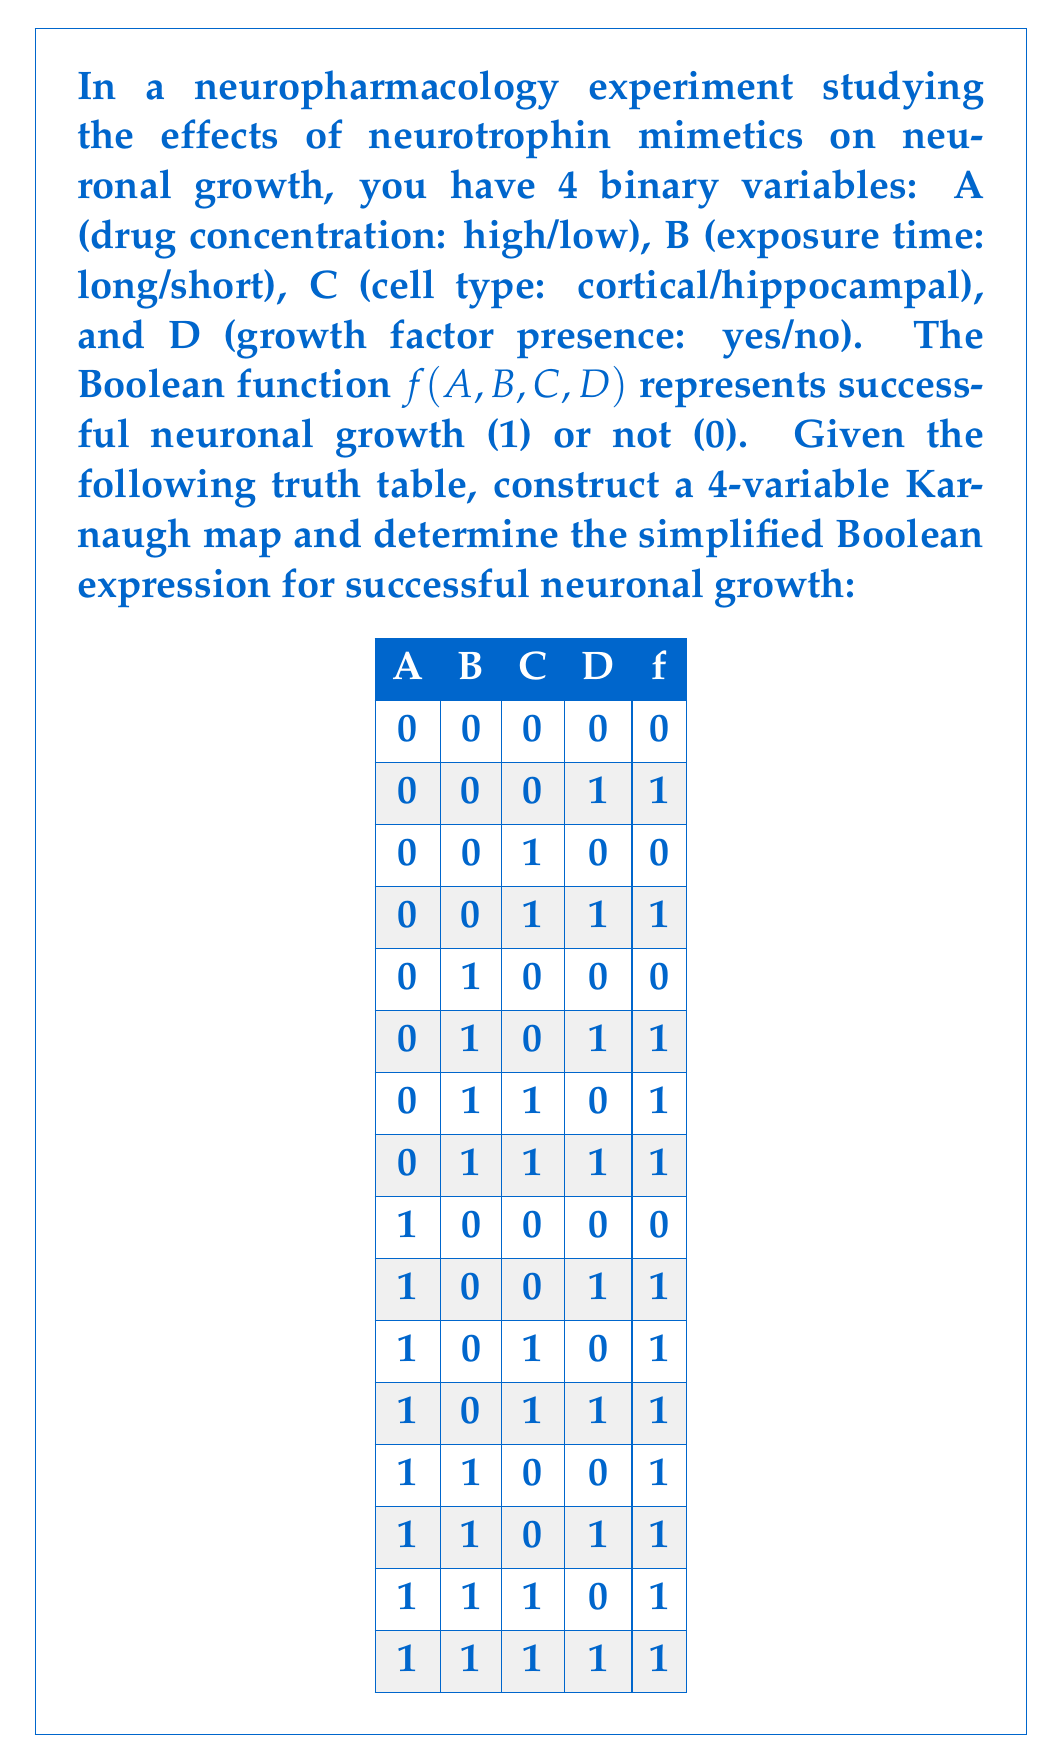Provide a solution to this math problem. To solve this problem, we'll follow these steps:

1. Construct the 4-variable Karnaugh map
2. Identify the largest possible groups of 1's
3. Write the simplified Boolean expression

Step 1: Constructing the 4-variable Karnaugh map

We'll use A and B for the rows, and C and D for the columns. The resulting map is:

[asy]
unitsize(1cm);

for(int i=0; i<5; ++i) {
  draw((0,i)--(4,i));
  draw((i,0)--(i,4));
}

label("AB\CD", (0,4.5));
label("00", (1,4.5));
label("01", (2,4.5));
label("11", (3,4.5));
label("10", (4,4.5));

label("00", (-0.5,3.5));
label("01", (-0.5,2.5));
label("11", (-0.5,1.5));
label("10", (-0.5,0.5));

label("0", (1,3.5));
label("1", (2,3.5));
label("1", (3,3.5));
label("1", (4,3.5));

label("0", (1,2.5));
label("1", (2,2.5));
label("1", (3,2.5));
label("1", (4,2.5));

label("1", (1,1.5));
label("1", (2,1.5));
label("1", (3,1.5));
label("1", (4,1.5));

label("0", (1,0.5));
label("1", (2,0.5));
label("1", (3,0.5));
label("1", (4,0.5));
[/asy]

Step 2: Identifying the largest possible groups of 1's

We can identify the following groups:
- A group of 8 1's covering the bottom half of the map (A = 1)
- A group of 4 1's in the right half of the second row (B = 1, C = 1)
- A group of 8 1's covering the right half of the map (D = 1)

Step 3: Writing the simplified Boolean expression

The simplified Boolean expression is the OR of these groups:

$$f(A,B,C,D) = A + BC + D$$

This expression represents the conditions for successful neuronal growth in our experiment:
- High drug concentration (A = 1), OR
- Long exposure time AND hippocampal cells (B = 1 AND C = 1), OR
- Presence of growth factor (D = 1)

This simplified expression helps optimize the experimental design by identifying the key factors and combinations that lead to successful neuronal growth.
Answer: $f(A,B,C,D) = A + BC + D$ 